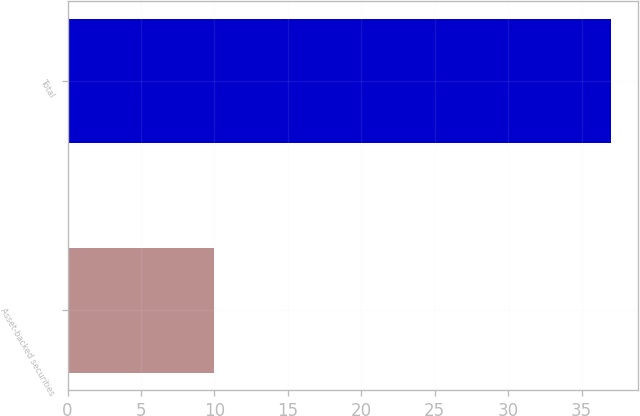Convert chart to OTSL. <chart><loc_0><loc_0><loc_500><loc_500><bar_chart><fcel>Asset-backed securities<fcel>Total<nl><fcel>10<fcel>37<nl></chart> 